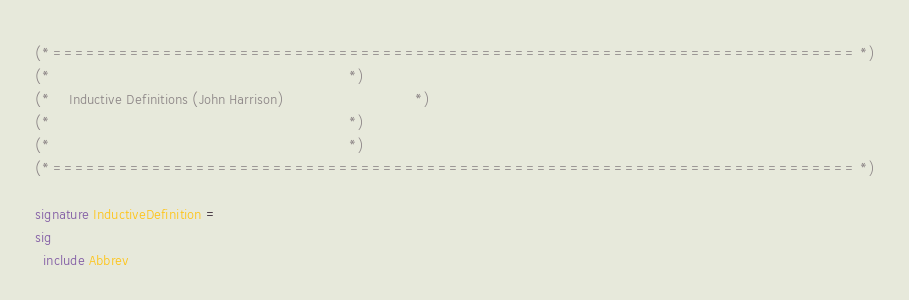Convert code to text. <code><loc_0><loc_0><loc_500><loc_500><_SML_>(* ========================================================================= *)
(*                                                                           *)
(*     Inductive Definitions (John Harrison)                                 *)
(*                                                                           *)
(*                                                                           *)
(* ========================================================================= *)

signature InductiveDefinition =
sig
  include Abbrev
</code> 